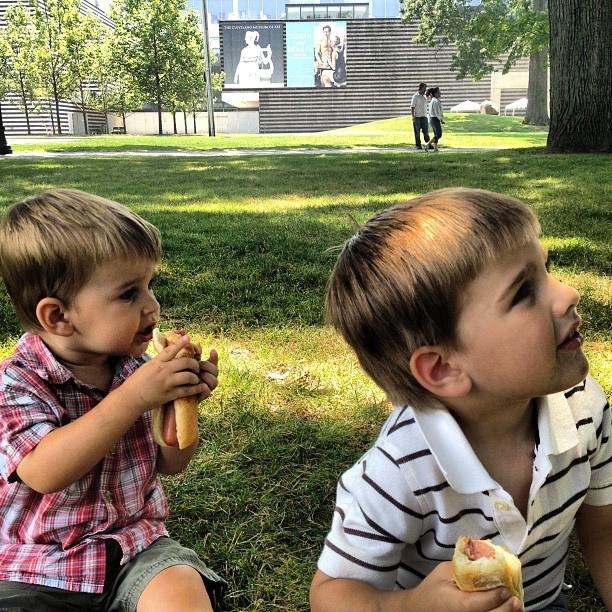What are the boys eating?
Write a very short answer. Hot dogs. Are they wearing matching shirts?
Be succinct. No. Are the boys sitting at a table?
Quick response, please. No. 